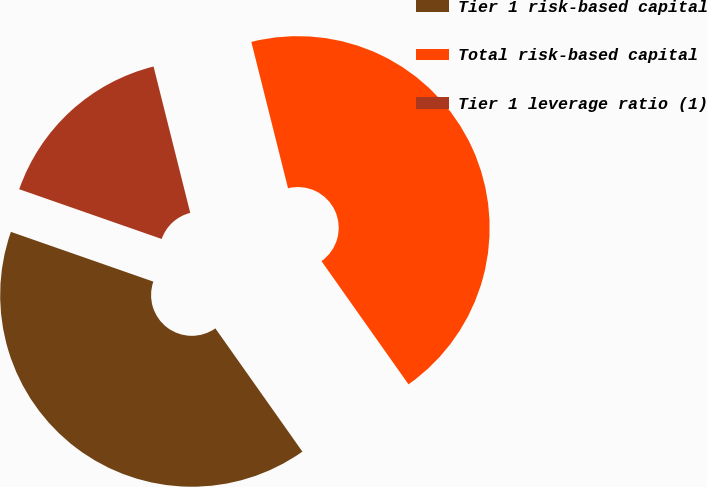Convert chart to OTSL. <chart><loc_0><loc_0><loc_500><loc_500><pie_chart><fcel>Tier 1 risk-based capital<fcel>Total risk-based capital<fcel>Tier 1 leverage ratio (1)<nl><fcel>40.13%<fcel>44.12%<fcel>15.74%<nl></chart> 